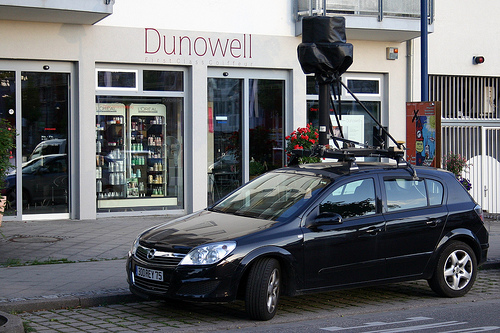<image>
Is the sensor next to the car? No. The sensor is not positioned next to the car. They are located in different areas of the scene. Where is the camera in relation to the shop? Is it in front of the shop? Yes. The camera is positioned in front of the shop, appearing closer to the camera viewpoint. 